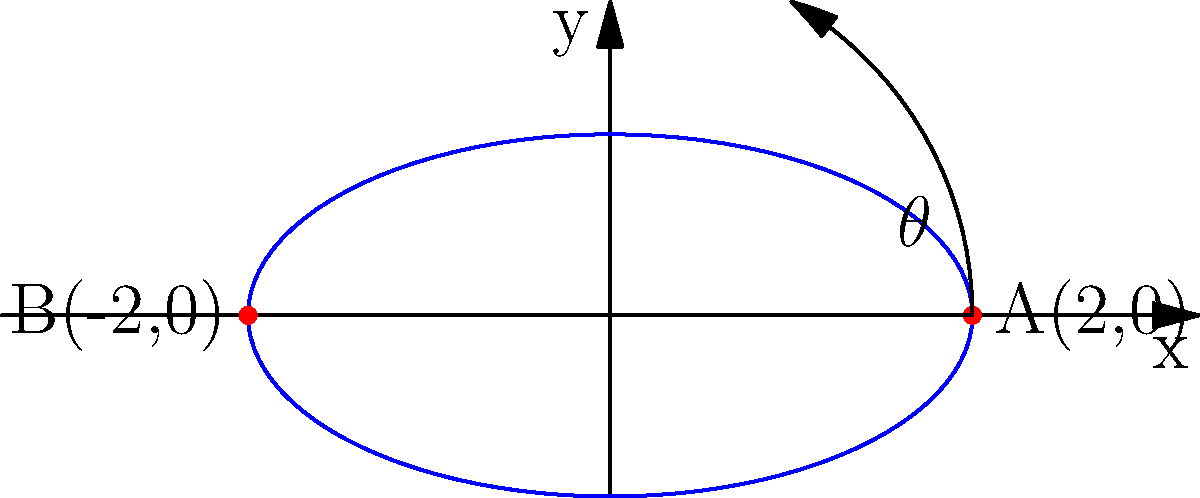You and your friend are studying the motion of a particle along the path given by $x=2\cos(t)$ and $y=\sin(t)$, where $t$ is in radians. At the point A(2,0), what is the rate of change of the particle's y-coordinate with respect to its x-coordinate? Let's approach this step-by-step:

1) We need to find $\frac{dy}{dx}$ at the point A(2,0).

2) We can use the chain rule: $\frac{dy}{dx} = \frac{dy/dt}{dx/dt}$

3) Let's find $\frac{dx}{dt}$ and $\frac{dy}{dt}$:
   $\frac{dx}{dt} = -2\sin(t)$
   $\frac{dy}{dt} = \cos(t)$

4) Now, $\frac{dy}{dx} = \frac{\cos(t)}{-2\sin(t)} = -\frac{1}{2}\cot(t)$

5) At point A(2,0), we have $x=2$ and $y=0$. This corresponds to $t=0$.

6) When $t=0$, $\cot(0)$ is undefined. However, we can find the limit:
   $\lim_{t \to 0} -\frac{1}{2}\cot(t) = -\frac{1}{2} \cdot \infty = -\infty$

7) Therefore, at point A, the rate of change of y with respect to x is approaching negative infinity.
Answer: $-\infty$ 